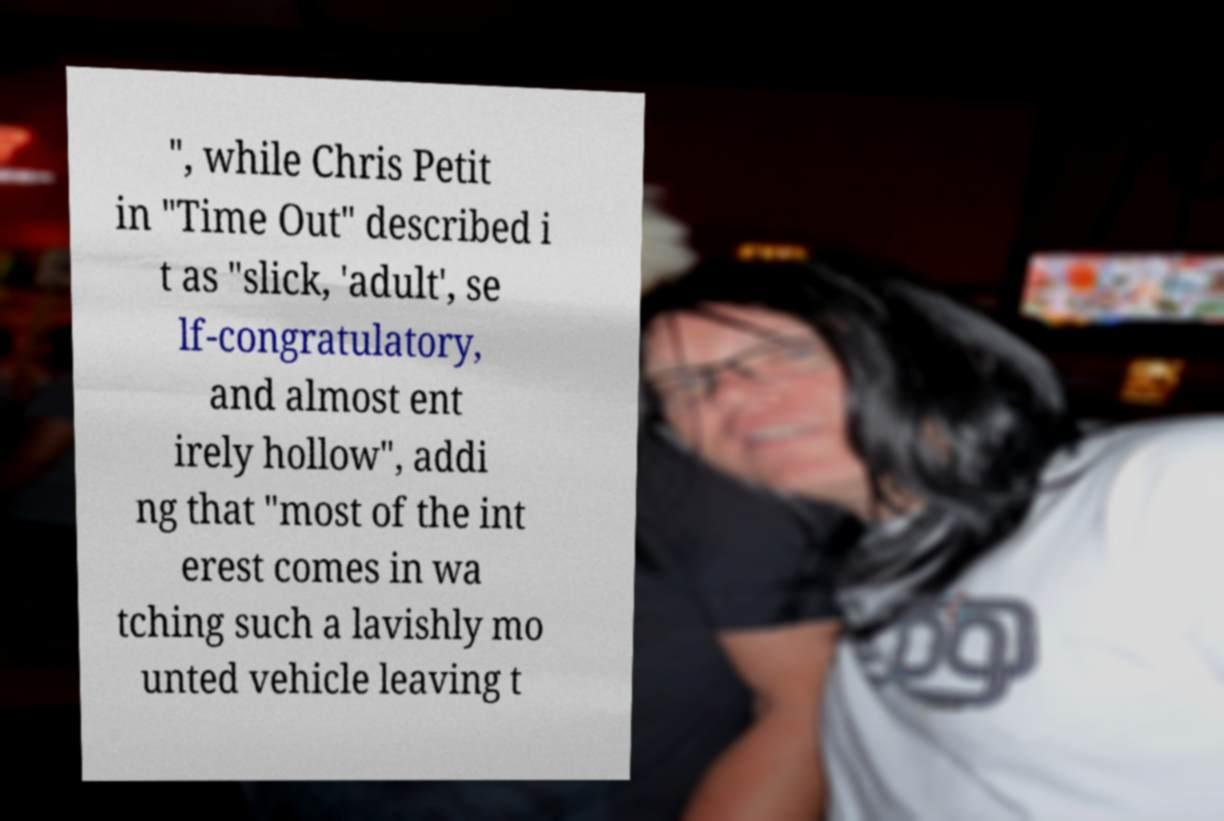I need the written content from this picture converted into text. Can you do that? ", while Chris Petit in "Time Out" described i t as "slick, 'adult', se lf-congratulatory, and almost ent irely hollow", addi ng that "most of the int erest comes in wa tching such a lavishly mo unted vehicle leaving t 